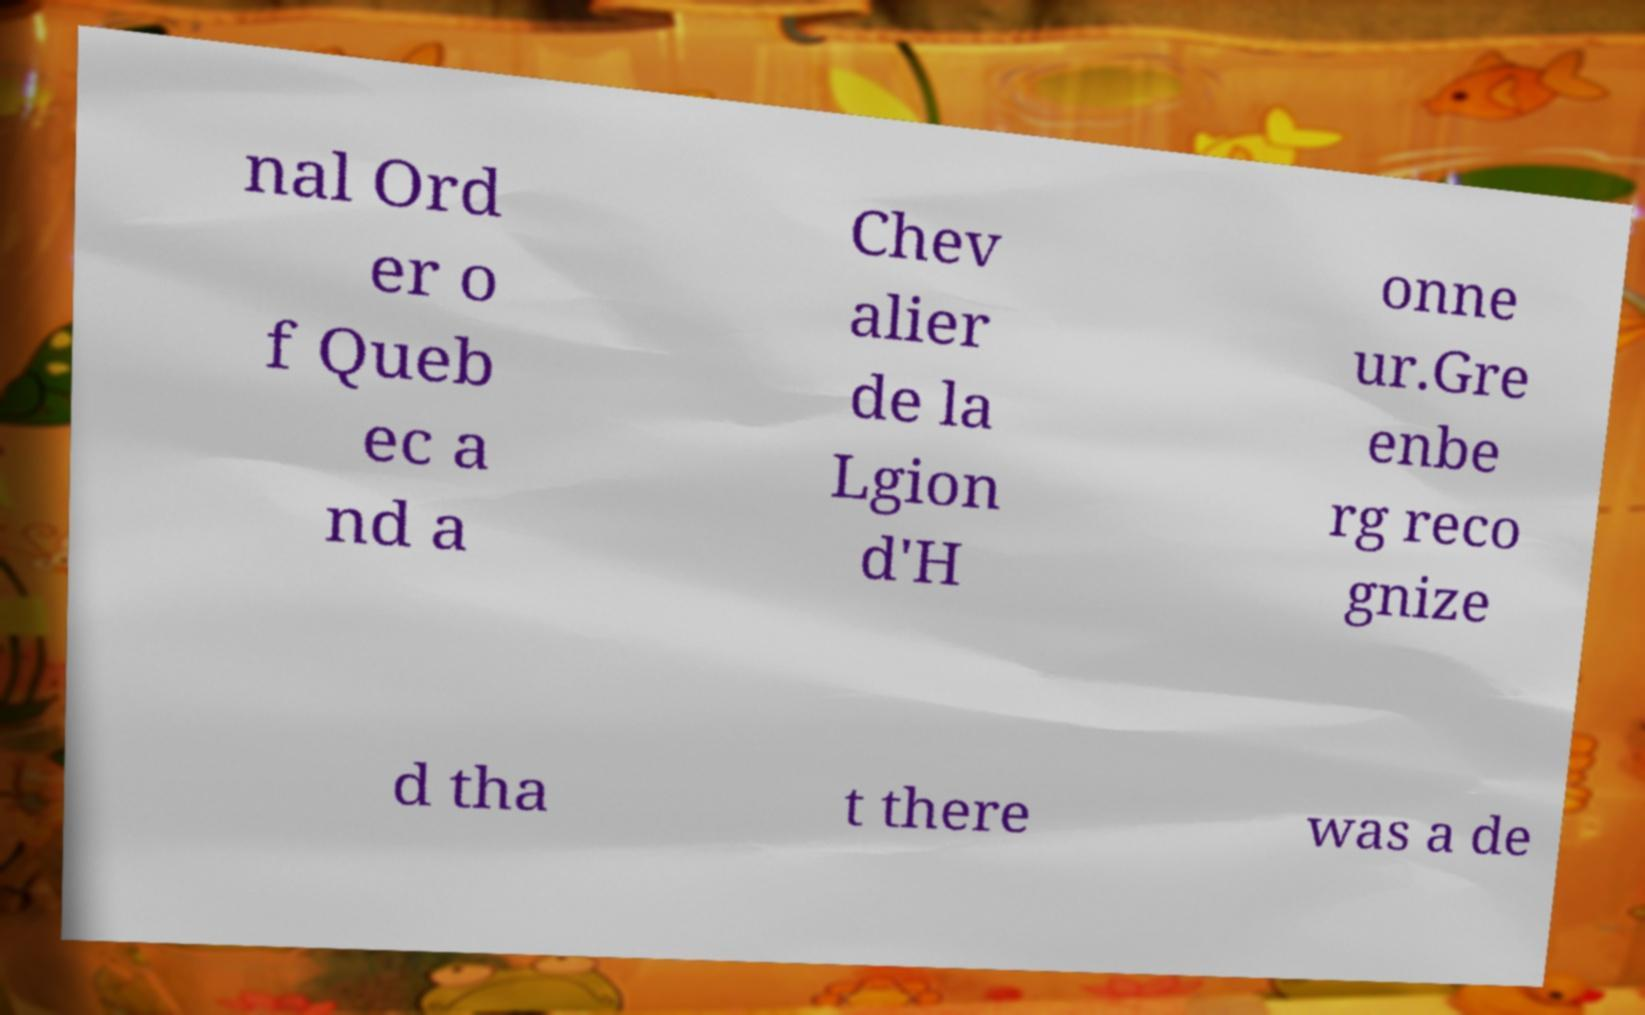For documentation purposes, I need the text within this image transcribed. Could you provide that? nal Ord er o f Queb ec a nd a Chev alier de la Lgion d'H onne ur.Gre enbe rg reco gnize d tha t there was a de 